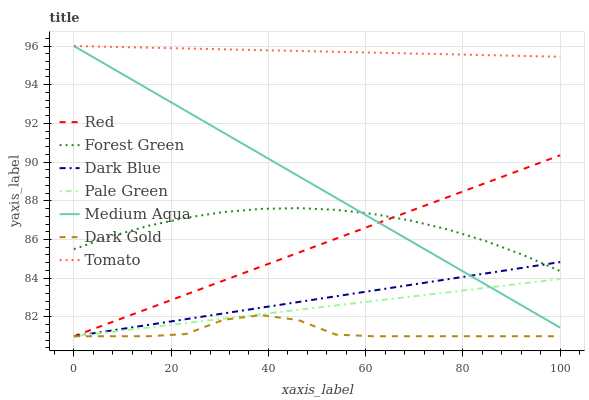Does Dark Blue have the minimum area under the curve?
Answer yes or no. No. Does Dark Blue have the maximum area under the curve?
Answer yes or no. No. Is Dark Blue the smoothest?
Answer yes or no. No. Is Dark Blue the roughest?
Answer yes or no. No. Does Forest Green have the lowest value?
Answer yes or no. No. Does Dark Blue have the highest value?
Answer yes or no. No. Is Dark Gold less than Forest Green?
Answer yes or no. Yes. Is Forest Green greater than Dark Gold?
Answer yes or no. Yes. Does Dark Gold intersect Forest Green?
Answer yes or no. No. 